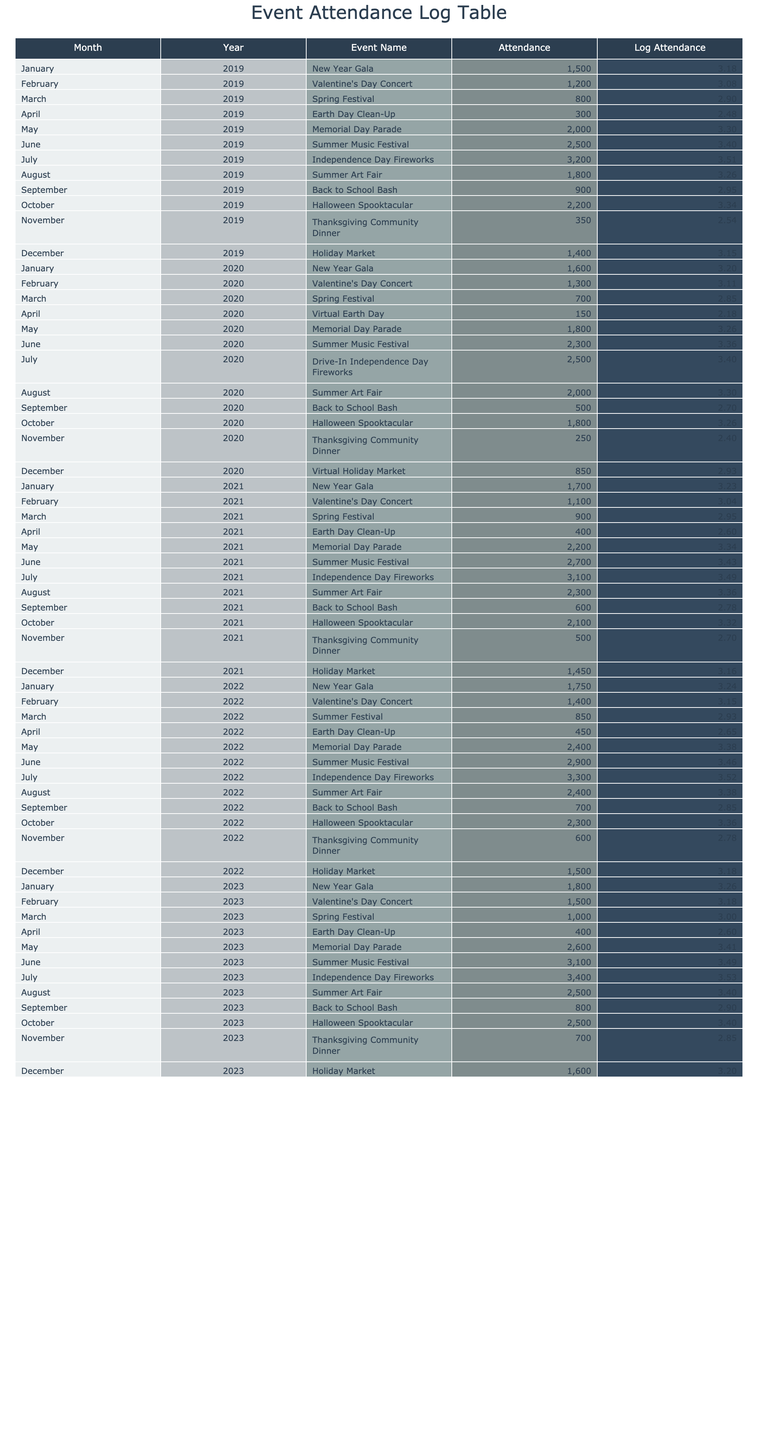What was the attendance for the Summer Music Festival in June 2022? The attendance for the Summer Music Festival in June 2022 can be located in the table under the June column for the year 2022. It shows a figure of 2900.
Answer: 2900 What is the log attendance for the Independence Day Fireworks in July 2023? To find the log attendance, we identify the attendance for the Independence Day Fireworks in July 2023, which is 3400, and apply the logarithm function: log10(3400) ≈ 3.531.
Answer: 3.531 How many events had attendance greater than 2500 from 2019 to 2023? We review the attendance figures for all events from 2019 to 2023, counting how many have values greater than 2500, which are: Summer Music Festival (June 2019: 2500), Independence Day Fireworks (July 2019: 3200), Summer Music Festival (June 2022: 2900), Independence Day Fireworks (July 2022: 3300), and Independence Day Fireworks (July 2023: 3400). There are 5 events.
Answer: 5 Is the attendance for Valentine's Day Concert in February 2020 higher than it was in February 2021? We compare the attendance numbers for both years; February 2020 shows 1300, while February 2021 shows 1100. Since 1300 is greater than 1100, the statement is true.
Answer: Yes What was the total attendance for all Thanksgiving Community Dinner events from 2019 to 2023? We need to sum the attendance figures for the Thanksgiving Community Dinner over the five years. These are: 350 (2019), 250 (2020), 500 (2021), 600 (2022), and 700 (2023). Performing the calculation gives: 350 + 250 + 500 + 600 + 700 = 2400.
Answer: 2400 What is the average attendance of the Summer Art Fair across the five years? The attendance figures for the Summer Art Fair are: 1800 (2019), 2000 (2020), 2300 (2021), 2400 (2022), and 2500 (2023). The total is calculated as: 1800 + 2000 + 2300 + 2400 + 2500 = 12200. Dividing this by the number of events (5) gives an average of: 12200 / 5 = 2440.
Answer: 2440 Was attendance for the Holiday Market in December 2023 the same as it was in December 2019? The attendance figures show 1400 for December 2019 and 1600 for December 2023. Since 1400 is not equal to 1600, we conclude that the attendance was not the same.
Answer: No How many events recorded less than 500 attendees from 2019 to 2023? We analyze the data and find that two events had attendance below 500: Virtual Earth Day (April 2020: 150) and Virtual Holiday Market (December 2020: 850). Hence, only one qualifies, which is the Virtual Earth Day.
Answer: 1 